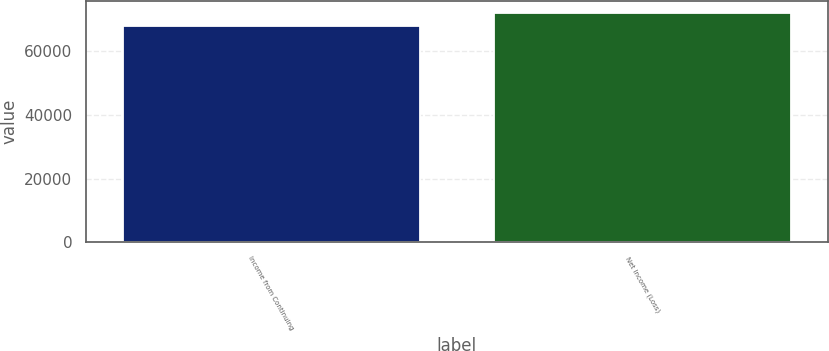<chart> <loc_0><loc_0><loc_500><loc_500><bar_chart><fcel>Income from Continuing<fcel>Net Income (Loss)<nl><fcel>67993<fcel>72106.2<nl></chart> 